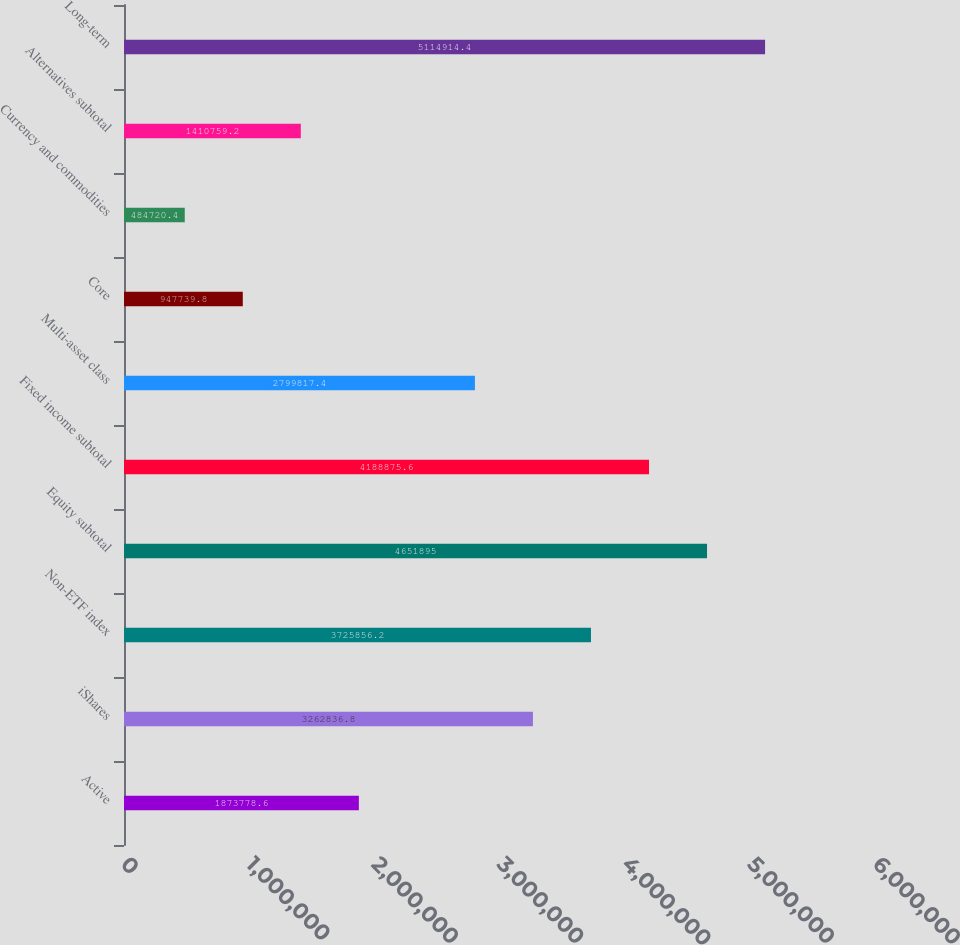Convert chart to OTSL. <chart><loc_0><loc_0><loc_500><loc_500><bar_chart><fcel>Active<fcel>iShares<fcel>Non-ETF index<fcel>Equity subtotal<fcel>Fixed income subtotal<fcel>Multi-asset class<fcel>Core<fcel>Currency and commodities<fcel>Alternatives subtotal<fcel>Long-term<nl><fcel>1.87378e+06<fcel>3.26284e+06<fcel>3.72586e+06<fcel>4.6519e+06<fcel>4.18888e+06<fcel>2.79982e+06<fcel>947740<fcel>484720<fcel>1.41076e+06<fcel>5.11491e+06<nl></chart> 